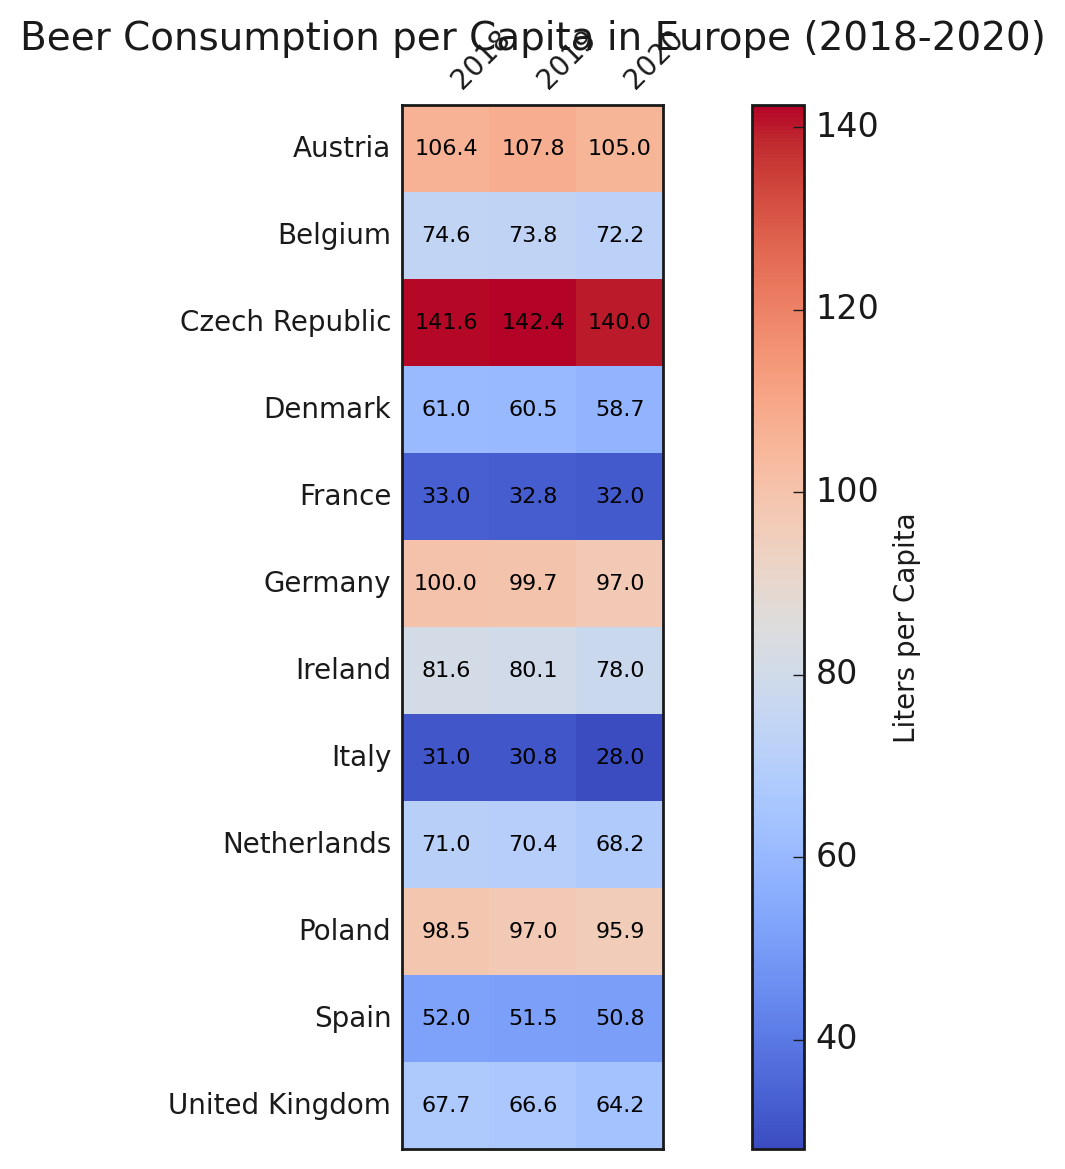Which country had the highest beer consumption per capita in 2020? By analyzing the figure, we identify the cell with the darkest color in the year 2020 column. The Czech Republic has the highest value of 140.0 liters per capita in 2020.
Answer: The Czech Republic What is the difference in beer consumption per capita between Germany and Poland in 2019? Locate the values for Germany and Poland in the 2019 column on the heatmap. Germany had 99.7 liters, and Poland had 97.0 liters. The difference is 99.7 - 97.0 = 2.7 liters.
Answer: 2.7 liters Among the countries shown, which one experienced the largest drop in beer consumption from 2019 to 2020? Check the differences in the values between 2019 and 2020 for all countries. Italy shows the largest drop from 30.8 in 2019 to 28.0 in 2020, a decrease of 2.8 liters.
Answer: Italy Which country had the lowest beer consumption per capita in 2018? Identify the cell with the lightest color in the year 2018 column. France had the lowest value of 33.0 liters per capita in 2018.
Answer: France How did the beer consumption trend for Belgium change from 2018 to 2020? Observe the values for Belgium across the years 2018, 2019, and 2020: 74.6, 73.8, and 72.2 liters per capita respectively. The trend shows a consistent decrease each year.
Answer: Decreasing trend Comparing the beer consumption between Austria and the United Kingdom in 2020, how much higher is Austria's? Look at the values for Austria and the UK in 2020. Austria had 105.0 liters per capita, while the UK had 64.2 liters. The difference is 105.0 - 64.2 = 40.8 liters.
Answer: 40.8 liters Which country had a consistent increase in beer consumption per capita from 2018 to 2019? Check the data for all countries from 2018 to 2019. Austria and the Czech Republic show consistent increases: Austria (106.4 to 107.8) and Czech Republic (141.6 to 142.4).
Answer: Austria, Czech Republic How much did beer consumption per capita decrease in Denmark from 2018 to 2020? Locate the values for Denmark in 2018 and 2020. In 2018, Denmark had 61.0 liters, and in 2020, it had 58.7 liters. The decrease is 61.0 - 58.7 = 2.3 liters.
Answer: 2.3 liters 